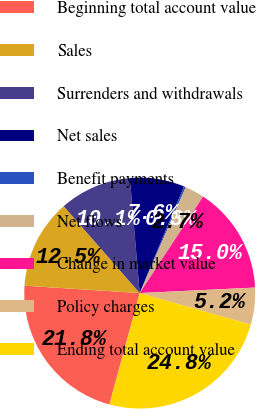<chart> <loc_0><loc_0><loc_500><loc_500><pie_chart><fcel>Beginning total account value<fcel>Sales<fcel>Surrenders and withdrawals<fcel>Net sales<fcel>Benefit payments<fcel>Net flows<fcel>Change in market value<fcel>Policy charges<fcel>Ending total account value<nl><fcel>21.79%<fcel>12.54%<fcel>10.08%<fcel>7.63%<fcel>0.26%<fcel>2.72%<fcel>14.99%<fcel>5.17%<fcel>24.82%<nl></chart> 